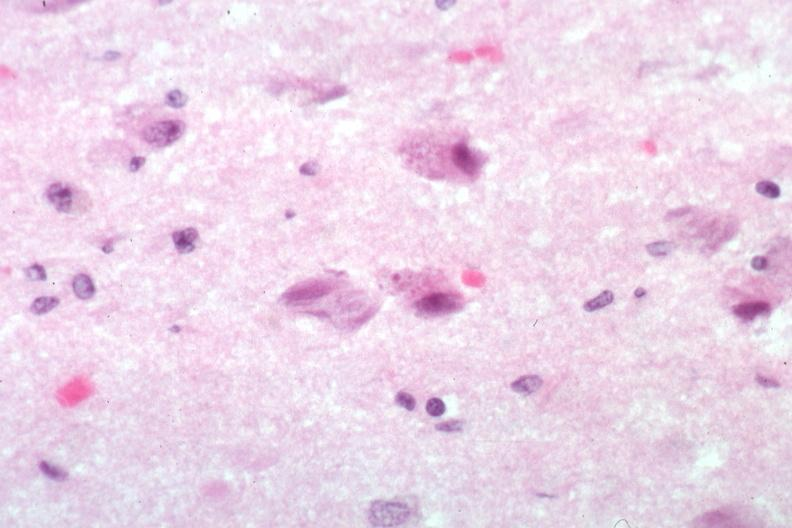s laceration present?
Answer the question using a single word or phrase. No 